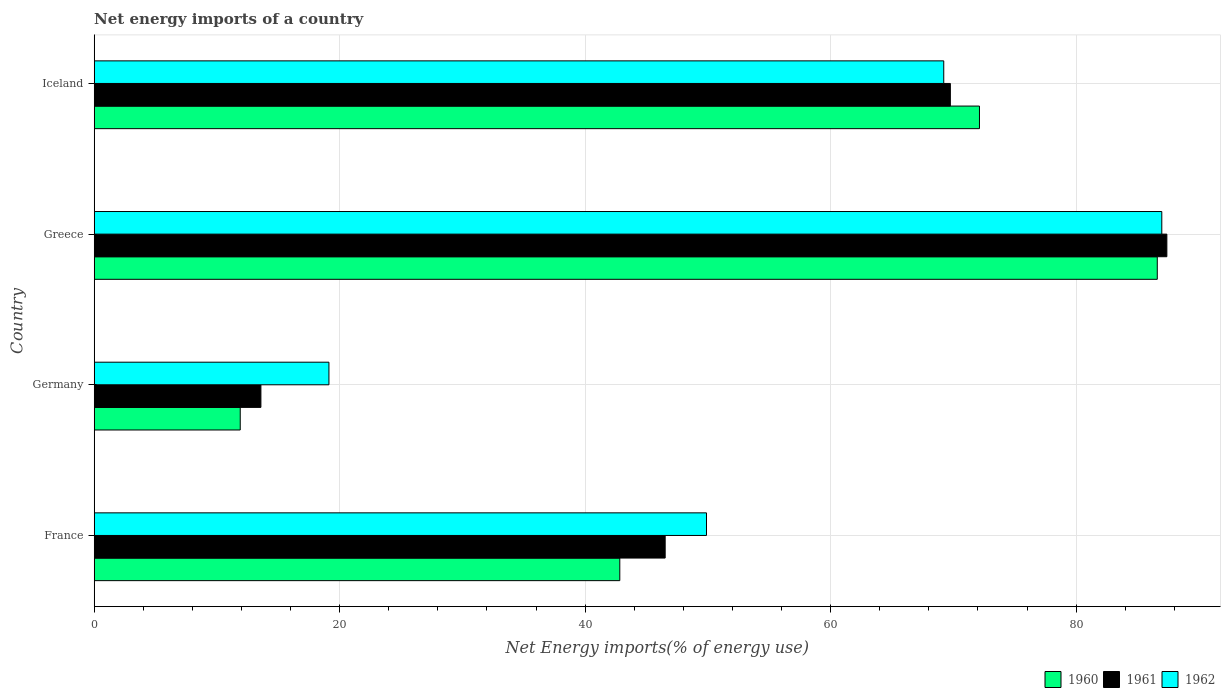How many groups of bars are there?
Offer a terse response. 4. Are the number of bars per tick equal to the number of legend labels?
Provide a short and direct response. Yes. Are the number of bars on each tick of the Y-axis equal?
Keep it short and to the point. Yes. How many bars are there on the 2nd tick from the bottom?
Offer a terse response. 3. In how many cases, is the number of bars for a given country not equal to the number of legend labels?
Provide a succinct answer. 0. What is the net energy imports in 1961 in Greece?
Make the answer very short. 87.4. Across all countries, what is the maximum net energy imports in 1961?
Offer a terse response. 87.4. Across all countries, what is the minimum net energy imports in 1960?
Offer a terse response. 11.9. In which country was the net energy imports in 1960 maximum?
Ensure brevity in your answer.  Greece. In which country was the net energy imports in 1961 minimum?
Keep it short and to the point. Germany. What is the total net energy imports in 1961 in the graph?
Give a very brief answer. 217.26. What is the difference between the net energy imports in 1962 in Germany and that in Greece?
Keep it short and to the point. -67.86. What is the difference between the net energy imports in 1962 in Iceland and the net energy imports in 1961 in France?
Give a very brief answer. 22.7. What is the average net energy imports in 1962 per country?
Give a very brief answer. 56.3. What is the difference between the net energy imports in 1961 and net energy imports in 1960 in France?
Offer a very short reply. 3.7. In how many countries, is the net energy imports in 1960 greater than 12 %?
Provide a succinct answer. 3. What is the ratio of the net energy imports in 1962 in Germany to that in Greece?
Ensure brevity in your answer.  0.22. Is the net energy imports in 1960 in Greece less than that in Iceland?
Keep it short and to the point. No. Is the difference between the net energy imports in 1961 in Germany and Iceland greater than the difference between the net energy imports in 1960 in Germany and Iceland?
Ensure brevity in your answer.  Yes. What is the difference between the highest and the second highest net energy imports in 1961?
Provide a short and direct response. 17.64. What is the difference between the highest and the lowest net energy imports in 1961?
Provide a short and direct response. 73.81. In how many countries, is the net energy imports in 1961 greater than the average net energy imports in 1961 taken over all countries?
Make the answer very short. 2. Is the sum of the net energy imports in 1961 in Germany and Iceland greater than the maximum net energy imports in 1960 across all countries?
Make the answer very short. No. What does the 2nd bar from the top in Greece represents?
Provide a short and direct response. 1961. What does the 1st bar from the bottom in Iceland represents?
Your response must be concise. 1960. How many bars are there?
Your answer should be very brief. 12. How many countries are there in the graph?
Give a very brief answer. 4. Where does the legend appear in the graph?
Your answer should be very brief. Bottom right. How many legend labels are there?
Provide a succinct answer. 3. What is the title of the graph?
Make the answer very short. Net energy imports of a country. What is the label or title of the X-axis?
Your response must be concise. Net Energy imports(% of energy use). What is the label or title of the Y-axis?
Your response must be concise. Country. What is the Net Energy imports(% of energy use) of 1960 in France?
Give a very brief answer. 42.82. What is the Net Energy imports(% of energy use) in 1961 in France?
Your response must be concise. 46.52. What is the Net Energy imports(% of energy use) of 1962 in France?
Provide a short and direct response. 49.89. What is the Net Energy imports(% of energy use) of 1960 in Germany?
Your answer should be compact. 11.9. What is the Net Energy imports(% of energy use) in 1961 in Germany?
Offer a terse response. 13.58. What is the Net Energy imports(% of energy use) in 1962 in Germany?
Keep it short and to the point. 19.13. What is the Net Energy imports(% of energy use) in 1960 in Greece?
Provide a short and direct response. 86.62. What is the Net Energy imports(% of energy use) of 1961 in Greece?
Provide a succinct answer. 87.4. What is the Net Energy imports(% of energy use) of 1962 in Greece?
Your answer should be compact. 86.98. What is the Net Energy imports(% of energy use) in 1960 in Iceland?
Your answer should be compact. 72.13. What is the Net Energy imports(% of energy use) of 1961 in Iceland?
Provide a short and direct response. 69.76. What is the Net Energy imports(% of energy use) in 1962 in Iceland?
Your response must be concise. 69.22. Across all countries, what is the maximum Net Energy imports(% of energy use) in 1960?
Your answer should be very brief. 86.62. Across all countries, what is the maximum Net Energy imports(% of energy use) of 1961?
Your answer should be compact. 87.4. Across all countries, what is the maximum Net Energy imports(% of energy use) in 1962?
Offer a terse response. 86.98. Across all countries, what is the minimum Net Energy imports(% of energy use) in 1960?
Your answer should be compact. 11.9. Across all countries, what is the minimum Net Energy imports(% of energy use) of 1961?
Offer a terse response. 13.58. Across all countries, what is the minimum Net Energy imports(% of energy use) in 1962?
Your answer should be very brief. 19.13. What is the total Net Energy imports(% of energy use) of 1960 in the graph?
Provide a succinct answer. 213.46. What is the total Net Energy imports(% of energy use) of 1961 in the graph?
Provide a succinct answer. 217.26. What is the total Net Energy imports(% of energy use) of 1962 in the graph?
Offer a very short reply. 225.21. What is the difference between the Net Energy imports(% of energy use) in 1960 in France and that in Germany?
Provide a short and direct response. 30.93. What is the difference between the Net Energy imports(% of energy use) of 1961 in France and that in Germany?
Your response must be concise. 32.94. What is the difference between the Net Energy imports(% of energy use) in 1962 in France and that in Germany?
Keep it short and to the point. 30.76. What is the difference between the Net Energy imports(% of energy use) in 1960 in France and that in Greece?
Provide a succinct answer. -43.79. What is the difference between the Net Energy imports(% of energy use) in 1961 in France and that in Greece?
Keep it short and to the point. -40.87. What is the difference between the Net Energy imports(% of energy use) in 1962 in France and that in Greece?
Your response must be concise. -37.09. What is the difference between the Net Energy imports(% of energy use) in 1960 in France and that in Iceland?
Make the answer very short. -29.3. What is the difference between the Net Energy imports(% of energy use) in 1961 in France and that in Iceland?
Provide a short and direct response. -23.24. What is the difference between the Net Energy imports(% of energy use) of 1962 in France and that in Iceland?
Give a very brief answer. -19.33. What is the difference between the Net Energy imports(% of energy use) in 1960 in Germany and that in Greece?
Offer a very short reply. -74.72. What is the difference between the Net Energy imports(% of energy use) of 1961 in Germany and that in Greece?
Give a very brief answer. -73.81. What is the difference between the Net Energy imports(% of energy use) in 1962 in Germany and that in Greece?
Your answer should be very brief. -67.86. What is the difference between the Net Energy imports(% of energy use) of 1960 in Germany and that in Iceland?
Provide a short and direct response. -60.23. What is the difference between the Net Energy imports(% of energy use) of 1961 in Germany and that in Iceland?
Your response must be concise. -56.17. What is the difference between the Net Energy imports(% of energy use) in 1962 in Germany and that in Iceland?
Keep it short and to the point. -50.09. What is the difference between the Net Energy imports(% of energy use) in 1960 in Greece and that in Iceland?
Offer a terse response. 14.49. What is the difference between the Net Energy imports(% of energy use) of 1961 in Greece and that in Iceland?
Provide a short and direct response. 17.64. What is the difference between the Net Energy imports(% of energy use) in 1962 in Greece and that in Iceland?
Provide a succinct answer. 17.77. What is the difference between the Net Energy imports(% of energy use) of 1960 in France and the Net Energy imports(% of energy use) of 1961 in Germany?
Your answer should be compact. 29.24. What is the difference between the Net Energy imports(% of energy use) in 1960 in France and the Net Energy imports(% of energy use) in 1962 in Germany?
Your response must be concise. 23.7. What is the difference between the Net Energy imports(% of energy use) of 1961 in France and the Net Energy imports(% of energy use) of 1962 in Germany?
Ensure brevity in your answer.  27.39. What is the difference between the Net Energy imports(% of energy use) of 1960 in France and the Net Energy imports(% of energy use) of 1961 in Greece?
Your response must be concise. -44.57. What is the difference between the Net Energy imports(% of energy use) in 1960 in France and the Net Energy imports(% of energy use) in 1962 in Greece?
Your response must be concise. -44.16. What is the difference between the Net Energy imports(% of energy use) of 1961 in France and the Net Energy imports(% of energy use) of 1962 in Greece?
Provide a short and direct response. -40.46. What is the difference between the Net Energy imports(% of energy use) of 1960 in France and the Net Energy imports(% of energy use) of 1961 in Iceland?
Offer a very short reply. -26.93. What is the difference between the Net Energy imports(% of energy use) of 1960 in France and the Net Energy imports(% of energy use) of 1962 in Iceland?
Your response must be concise. -26.39. What is the difference between the Net Energy imports(% of energy use) in 1961 in France and the Net Energy imports(% of energy use) in 1962 in Iceland?
Make the answer very short. -22.7. What is the difference between the Net Energy imports(% of energy use) of 1960 in Germany and the Net Energy imports(% of energy use) of 1961 in Greece?
Your answer should be compact. -75.5. What is the difference between the Net Energy imports(% of energy use) in 1960 in Germany and the Net Energy imports(% of energy use) in 1962 in Greece?
Ensure brevity in your answer.  -75.08. What is the difference between the Net Energy imports(% of energy use) in 1961 in Germany and the Net Energy imports(% of energy use) in 1962 in Greece?
Ensure brevity in your answer.  -73.4. What is the difference between the Net Energy imports(% of energy use) of 1960 in Germany and the Net Energy imports(% of energy use) of 1961 in Iceland?
Make the answer very short. -57.86. What is the difference between the Net Energy imports(% of energy use) in 1960 in Germany and the Net Energy imports(% of energy use) in 1962 in Iceland?
Provide a short and direct response. -57.32. What is the difference between the Net Energy imports(% of energy use) in 1961 in Germany and the Net Energy imports(% of energy use) in 1962 in Iceland?
Keep it short and to the point. -55.63. What is the difference between the Net Energy imports(% of energy use) of 1960 in Greece and the Net Energy imports(% of energy use) of 1961 in Iceland?
Provide a short and direct response. 16.86. What is the difference between the Net Energy imports(% of energy use) of 1960 in Greece and the Net Energy imports(% of energy use) of 1962 in Iceland?
Provide a short and direct response. 17.4. What is the difference between the Net Energy imports(% of energy use) of 1961 in Greece and the Net Energy imports(% of energy use) of 1962 in Iceland?
Ensure brevity in your answer.  18.18. What is the average Net Energy imports(% of energy use) in 1960 per country?
Provide a short and direct response. 53.37. What is the average Net Energy imports(% of energy use) of 1961 per country?
Your answer should be very brief. 54.31. What is the average Net Energy imports(% of energy use) in 1962 per country?
Provide a short and direct response. 56.3. What is the difference between the Net Energy imports(% of energy use) in 1960 and Net Energy imports(% of energy use) in 1961 in France?
Ensure brevity in your answer.  -3.7. What is the difference between the Net Energy imports(% of energy use) in 1960 and Net Energy imports(% of energy use) in 1962 in France?
Offer a very short reply. -7.06. What is the difference between the Net Energy imports(% of energy use) in 1961 and Net Energy imports(% of energy use) in 1962 in France?
Keep it short and to the point. -3.37. What is the difference between the Net Energy imports(% of energy use) of 1960 and Net Energy imports(% of energy use) of 1961 in Germany?
Offer a terse response. -1.68. What is the difference between the Net Energy imports(% of energy use) of 1960 and Net Energy imports(% of energy use) of 1962 in Germany?
Provide a short and direct response. -7.23. What is the difference between the Net Energy imports(% of energy use) in 1961 and Net Energy imports(% of energy use) in 1962 in Germany?
Offer a very short reply. -5.54. What is the difference between the Net Energy imports(% of energy use) of 1960 and Net Energy imports(% of energy use) of 1961 in Greece?
Your response must be concise. -0.78. What is the difference between the Net Energy imports(% of energy use) of 1960 and Net Energy imports(% of energy use) of 1962 in Greece?
Your answer should be very brief. -0.37. What is the difference between the Net Energy imports(% of energy use) of 1961 and Net Energy imports(% of energy use) of 1962 in Greece?
Make the answer very short. 0.41. What is the difference between the Net Energy imports(% of energy use) of 1960 and Net Energy imports(% of energy use) of 1961 in Iceland?
Keep it short and to the point. 2.37. What is the difference between the Net Energy imports(% of energy use) of 1960 and Net Energy imports(% of energy use) of 1962 in Iceland?
Your response must be concise. 2.91. What is the difference between the Net Energy imports(% of energy use) in 1961 and Net Energy imports(% of energy use) in 1962 in Iceland?
Provide a succinct answer. 0.54. What is the ratio of the Net Energy imports(% of energy use) in 1960 in France to that in Germany?
Ensure brevity in your answer.  3.6. What is the ratio of the Net Energy imports(% of energy use) of 1961 in France to that in Germany?
Ensure brevity in your answer.  3.43. What is the ratio of the Net Energy imports(% of energy use) in 1962 in France to that in Germany?
Your answer should be very brief. 2.61. What is the ratio of the Net Energy imports(% of energy use) in 1960 in France to that in Greece?
Keep it short and to the point. 0.49. What is the ratio of the Net Energy imports(% of energy use) of 1961 in France to that in Greece?
Ensure brevity in your answer.  0.53. What is the ratio of the Net Energy imports(% of energy use) of 1962 in France to that in Greece?
Provide a succinct answer. 0.57. What is the ratio of the Net Energy imports(% of energy use) in 1960 in France to that in Iceland?
Provide a succinct answer. 0.59. What is the ratio of the Net Energy imports(% of energy use) in 1961 in France to that in Iceland?
Offer a terse response. 0.67. What is the ratio of the Net Energy imports(% of energy use) of 1962 in France to that in Iceland?
Your answer should be very brief. 0.72. What is the ratio of the Net Energy imports(% of energy use) in 1960 in Germany to that in Greece?
Make the answer very short. 0.14. What is the ratio of the Net Energy imports(% of energy use) of 1961 in Germany to that in Greece?
Your response must be concise. 0.16. What is the ratio of the Net Energy imports(% of energy use) of 1962 in Germany to that in Greece?
Offer a terse response. 0.22. What is the ratio of the Net Energy imports(% of energy use) in 1960 in Germany to that in Iceland?
Your answer should be very brief. 0.17. What is the ratio of the Net Energy imports(% of energy use) in 1961 in Germany to that in Iceland?
Your answer should be very brief. 0.19. What is the ratio of the Net Energy imports(% of energy use) of 1962 in Germany to that in Iceland?
Keep it short and to the point. 0.28. What is the ratio of the Net Energy imports(% of energy use) of 1960 in Greece to that in Iceland?
Keep it short and to the point. 1.2. What is the ratio of the Net Energy imports(% of energy use) of 1961 in Greece to that in Iceland?
Offer a terse response. 1.25. What is the ratio of the Net Energy imports(% of energy use) of 1962 in Greece to that in Iceland?
Your answer should be very brief. 1.26. What is the difference between the highest and the second highest Net Energy imports(% of energy use) in 1960?
Offer a very short reply. 14.49. What is the difference between the highest and the second highest Net Energy imports(% of energy use) of 1961?
Offer a very short reply. 17.64. What is the difference between the highest and the second highest Net Energy imports(% of energy use) of 1962?
Your answer should be very brief. 17.77. What is the difference between the highest and the lowest Net Energy imports(% of energy use) of 1960?
Provide a short and direct response. 74.72. What is the difference between the highest and the lowest Net Energy imports(% of energy use) of 1961?
Your answer should be compact. 73.81. What is the difference between the highest and the lowest Net Energy imports(% of energy use) of 1962?
Provide a short and direct response. 67.86. 